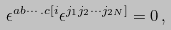<formula> <loc_0><loc_0><loc_500><loc_500>\epsilon ^ { a b \cdots . c [ i } \epsilon ^ { j _ { 1 } j _ { 2 } \cdots j _ { 2 N } ] } = 0 \, ,</formula> 